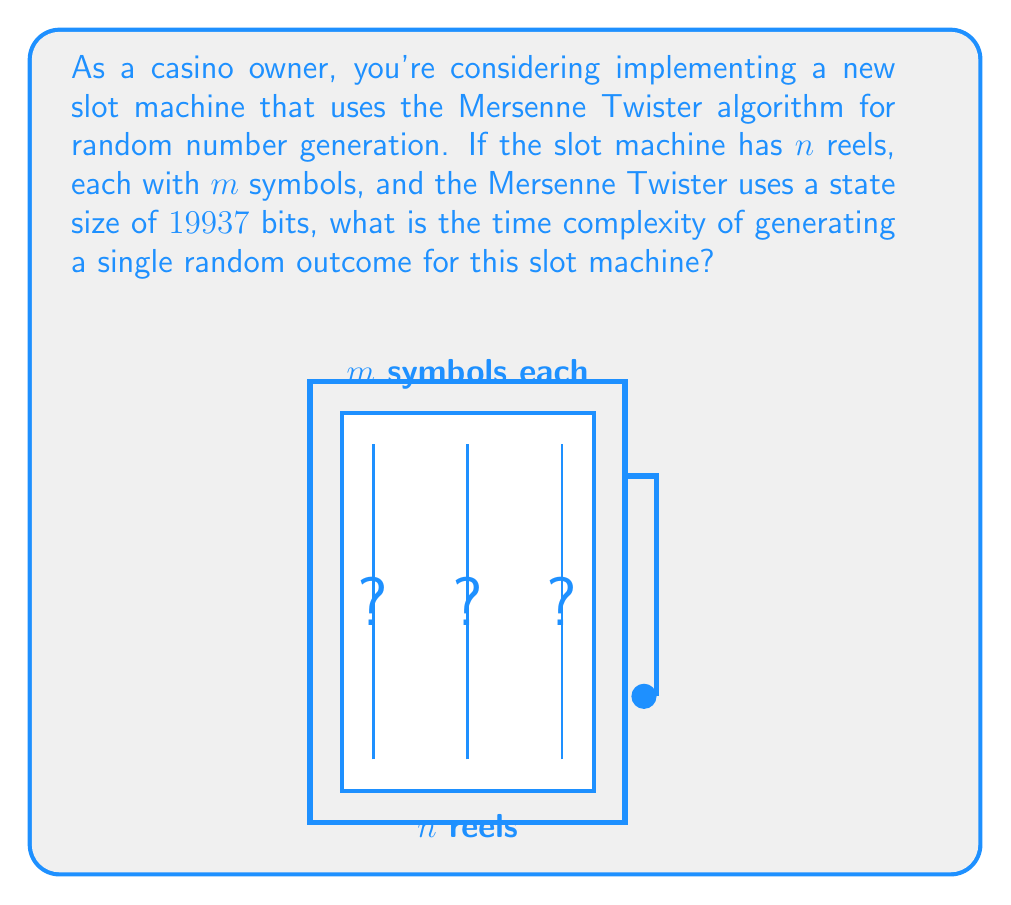Give your solution to this math problem. To analyze the time complexity of generating a single random outcome for this slot machine, we need to consider the following steps:

1) The Mersenne Twister algorithm:
   - It has a state size of 19937 bits, which is constant regardless of $n$ and $m$.
   - Generating a single random number using Mersenne Twister has a time complexity of $O(1)$.

2) Number of random numbers needed:
   - We need to generate a random number for each reel.
   - There are $n$ reels, so we need $n$ random numbers.

3) Mapping random numbers to symbols:
   - Each reel has $m$ symbols.
   - Mapping a random number to a symbol typically involves a modulo operation, which is $O(1)$.

4) Overall process:
   - Generate $n$ random numbers: $O(n)$
   - Map each number to a symbol: $O(n)$

Therefore, the total time complexity is $O(n)$, linear in the number of reels.

It's important to note that this complexity is independent of $m$ (the number of symbols per reel) because the modulo operation to map a random number to a symbol is constant time regardless of the number of symbols.

The space complexity of the Mersenne Twister (19937 bits of state) is constant and doesn't affect the time complexity of generating a single outcome.
Answer: $O(n)$ 